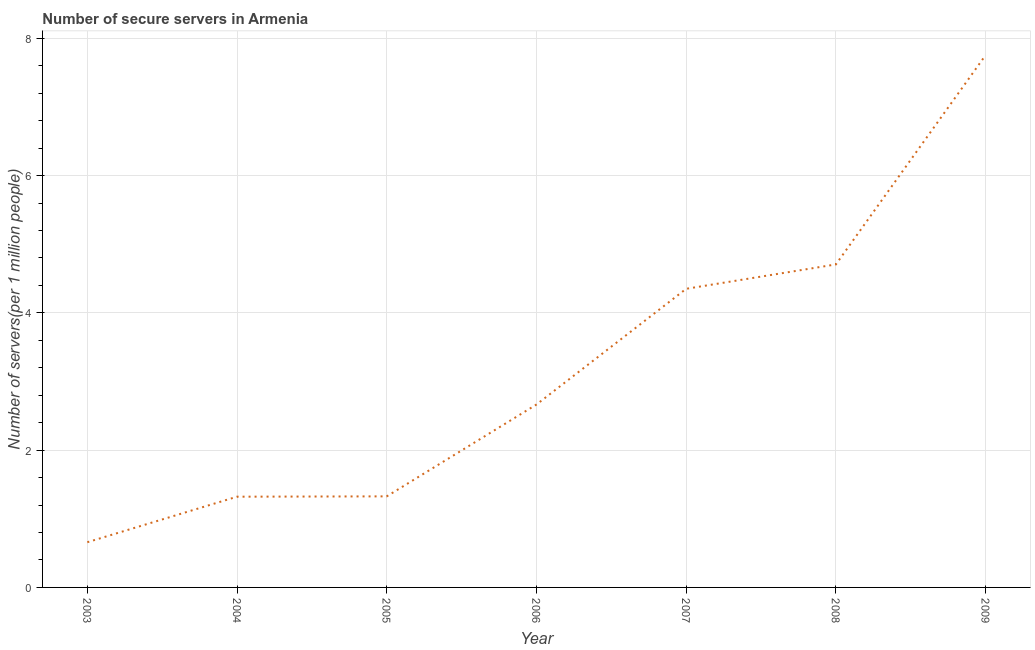What is the number of secure internet servers in 2003?
Your answer should be very brief. 0.66. Across all years, what is the maximum number of secure internet servers?
Make the answer very short. 7.75. Across all years, what is the minimum number of secure internet servers?
Provide a short and direct response. 0.66. What is the sum of the number of secure internet servers?
Provide a succinct answer. 22.78. What is the difference between the number of secure internet servers in 2003 and 2005?
Give a very brief answer. -0.67. What is the average number of secure internet servers per year?
Provide a succinct answer. 3.25. What is the median number of secure internet servers?
Your answer should be compact. 2.66. In how many years, is the number of secure internet servers greater than 2.4 ?
Give a very brief answer. 4. Do a majority of the years between 2003 and 2008 (inclusive) have number of secure internet servers greater than 0.8 ?
Give a very brief answer. Yes. What is the ratio of the number of secure internet servers in 2007 to that in 2009?
Make the answer very short. 0.56. Is the number of secure internet servers in 2008 less than that in 2009?
Offer a terse response. Yes. What is the difference between the highest and the second highest number of secure internet servers?
Keep it short and to the point. 3.05. Is the sum of the number of secure internet servers in 2007 and 2008 greater than the maximum number of secure internet servers across all years?
Your answer should be compact. Yes. What is the difference between the highest and the lowest number of secure internet servers?
Your response must be concise. 7.1. In how many years, is the number of secure internet servers greater than the average number of secure internet servers taken over all years?
Provide a succinct answer. 3. How many lines are there?
Provide a succinct answer. 1. How many years are there in the graph?
Provide a succinct answer. 7. What is the title of the graph?
Your response must be concise. Number of secure servers in Armenia. What is the label or title of the X-axis?
Offer a terse response. Year. What is the label or title of the Y-axis?
Provide a short and direct response. Number of servers(per 1 million people). What is the Number of servers(per 1 million people) in 2003?
Your response must be concise. 0.66. What is the Number of servers(per 1 million people) in 2004?
Keep it short and to the point. 1.32. What is the Number of servers(per 1 million people) of 2005?
Give a very brief answer. 1.33. What is the Number of servers(per 1 million people) of 2006?
Your answer should be very brief. 2.66. What is the Number of servers(per 1 million people) in 2007?
Provide a succinct answer. 4.35. What is the Number of servers(per 1 million people) of 2008?
Give a very brief answer. 4.71. What is the Number of servers(per 1 million people) of 2009?
Your answer should be compact. 7.75. What is the difference between the Number of servers(per 1 million people) in 2003 and 2004?
Offer a very short reply. -0.66. What is the difference between the Number of servers(per 1 million people) in 2003 and 2005?
Keep it short and to the point. -0.67. What is the difference between the Number of servers(per 1 million people) in 2003 and 2006?
Ensure brevity in your answer.  -2.01. What is the difference between the Number of servers(per 1 million people) in 2003 and 2007?
Make the answer very short. -3.69. What is the difference between the Number of servers(per 1 million people) in 2003 and 2008?
Ensure brevity in your answer.  -4.05. What is the difference between the Number of servers(per 1 million people) in 2003 and 2009?
Make the answer very short. -7.1. What is the difference between the Number of servers(per 1 million people) in 2004 and 2005?
Your response must be concise. -0. What is the difference between the Number of servers(per 1 million people) in 2004 and 2006?
Provide a succinct answer. -1.34. What is the difference between the Number of servers(per 1 million people) in 2004 and 2007?
Your answer should be very brief. -3.03. What is the difference between the Number of servers(per 1 million people) in 2004 and 2008?
Provide a short and direct response. -3.38. What is the difference between the Number of servers(per 1 million people) in 2004 and 2009?
Your answer should be very brief. -6.43. What is the difference between the Number of servers(per 1 million people) in 2005 and 2006?
Offer a very short reply. -1.34. What is the difference between the Number of servers(per 1 million people) in 2005 and 2007?
Your answer should be compact. -3.02. What is the difference between the Number of servers(per 1 million people) in 2005 and 2008?
Make the answer very short. -3.38. What is the difference between the Number of servers(per 1 million people) in 2005 and 2009?
Give a very brief answer. -6.43. What is the difference between the Number of servers(per 1 million people) in 2006 and 2007?
Give a very brief answer. -1.69. What is the difference between the Number of servers(per 1 million people) in 2006 and 2008?
Your answer should be compact. -2.04. What is the difference between the Number of servers(per 1 million people) in 2006 and 2009?
Make the answer very short. -5.09. What is the difference between the Number of servers(per 1 million people) in 2007 and 2008?
Your answer should be compact. -0.36. What is the difference between the Number of servers(per 1 million people) in 2007 and 2009?
Keep it short and to the point. -3.4. What is the difference between the Number of servers(per 1 million people) in 2008 and 2009?
Your answer should be very brief. -3.05. What is the ratio of the Number of servers(per 1 million people) in 2003 to that in 2004?
Make the answer very short. 0.5. What is the ratio of the Number of servers(per 1 million people) in 2003 to that in 2005?
Offer a terse response. 0.5. What is the ratio of the Number of servers(per 1 million people) in 2003 to that in 2006?
Give a very brief answer. 0.25. What is the ratio of the Number of servers(per 1 million people) in 2003 to that in 2007?
Provide a short and direct response. 0.15. What is the ratio of the Number of servers(per 1 million people) in 2003 to that in 2008?
Your response must be concise. 0.14. What is the ratio of the Number of servers(per 1 million people) in 2003 to that in 2009?
Provide a succinct answer. 0.09. What is the ratio of the Number of servers(per 1 million people) in 2004 to that in 2006?
Your answer should be very brief. 0.5. What is the ratio of the Number of servers(per 1 million people) in 2004 to that in 2007?
Make the answer very short. 0.3. What is the ratio of the Number of servers(per 1 million people) in 2004 to that in 2008?
Give a very brief answer. 0.28. What is the ratio of the Number of servers(per 1 million people) in 2004 to that in 2009?
Your response must be concise. 0.17. What is the ratio of the Number of servers(per 1 million people) in 2005 to that in 2006?
Give a very brief answer. 0.5. What is the ratio of the Number of servers(per 1 million people) in 2005 to that in 2007?
Provide a short and direct response. 0.3. What is the ratio of the Number of servers(per 1 million people) in 2005 to that in 2008?
Make the answer very short. 0.28. What is the ratio of the Number of servers(per 1 million people) in 2005 to that in 2009?
Your answer should be compact. 0.17. What is the ratio of the Number of servers(per 1 million people) in 2006 to that in 2007?
Keep it short and to the point. 0.61. What is the ratio of the Number of servers(per 1 million people) in 2006 to that in 2008?
Provide a succinct answer. 0.57. What is the ratio of the Number of servers(per 1 million people) in 2006 to that in 2009?
Ensure brevity in your answer.  0.34. What is the ratio of the Number of servers(per 1 million people) in 2007 to that in 2008?
Your answer should be very brief. 0.93. What is the ratio of the Number of servers(per 1 million people) in 2007 to that in 2009?
Your answer should be compact. 0.56. What is the ratio of the Number of servers(per 1 million people) in 2008 to that in 2009?
Give a very brief answer. 0.61. 